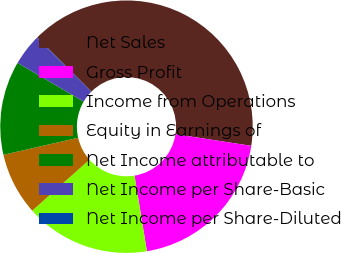Convert chart to OTSL. <chart><loc_0><loc_0><loc_500><loc_500><pie_chart><fcel>Net Sales<fcel>Gross Profit<fcel>Income from Operations<fcel>Equity in Earnings of<fcel>Net Income attributable to<fcel>Net Income per Share-Basic<fcel>Net Income per Share-Diluted<nl><fcel>39.94%<fcel>19.99%<fcel>16.0%<fcel>8.01%<fcel>12.01%<fcel>4.02%<fcel>0.03%<nl></chart> 